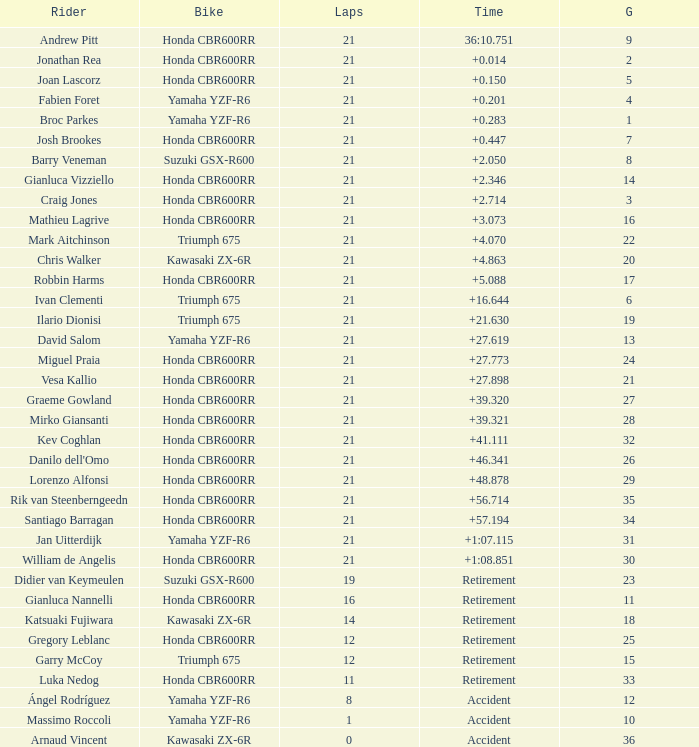What is the total number of laps completed by a driver who has a grid position below 17 and a time of +5.088? None. 